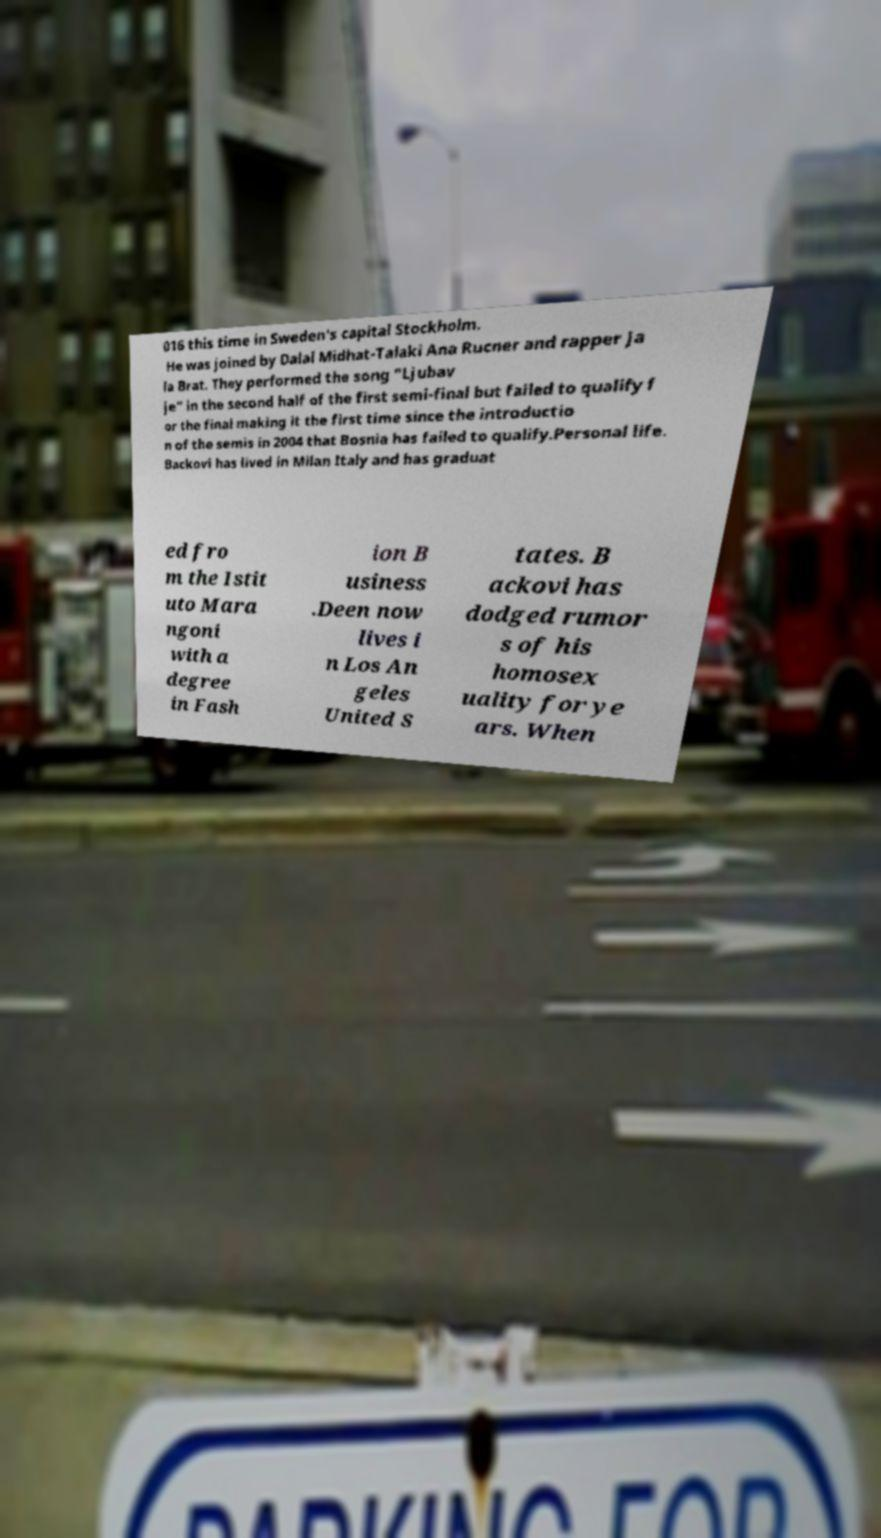Please read and relay the text visible in this image. What does it say? 016 this time in Sweden's capital Stockholm. He was joined by Dalal Midhat-Talaki Ana Rucner and rapper Ja la Brat. They performed the song "Ljubav je" in the second half of the first semi-final but failed to qualify f or the final making it the first time since the introductio n of the semis in 2004 that Bosnia has failed to qualify.Personal life. Backovi has lived in Milan Italy and has graduat ed fro m the Istit uto Mara ngoni with a degree in Fash ion B usiness .Deen now lives i n Los An geles United S tates. B ackovi has dodged rumor s of his homosex uality for ye ars. When 